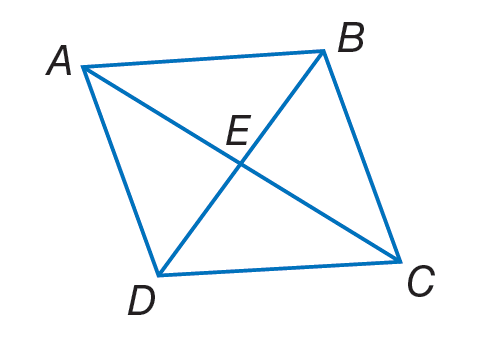Answer the mathemtical geometry problem and directly provide the correct option letter.
Question: A B C D is a rhombus. If E B = 9, A B = 12 and m \angle A B D = 55. Find A E.
Choices: A: \sqrt { 63 } B: 8 C: 12.5 D: 81 A 